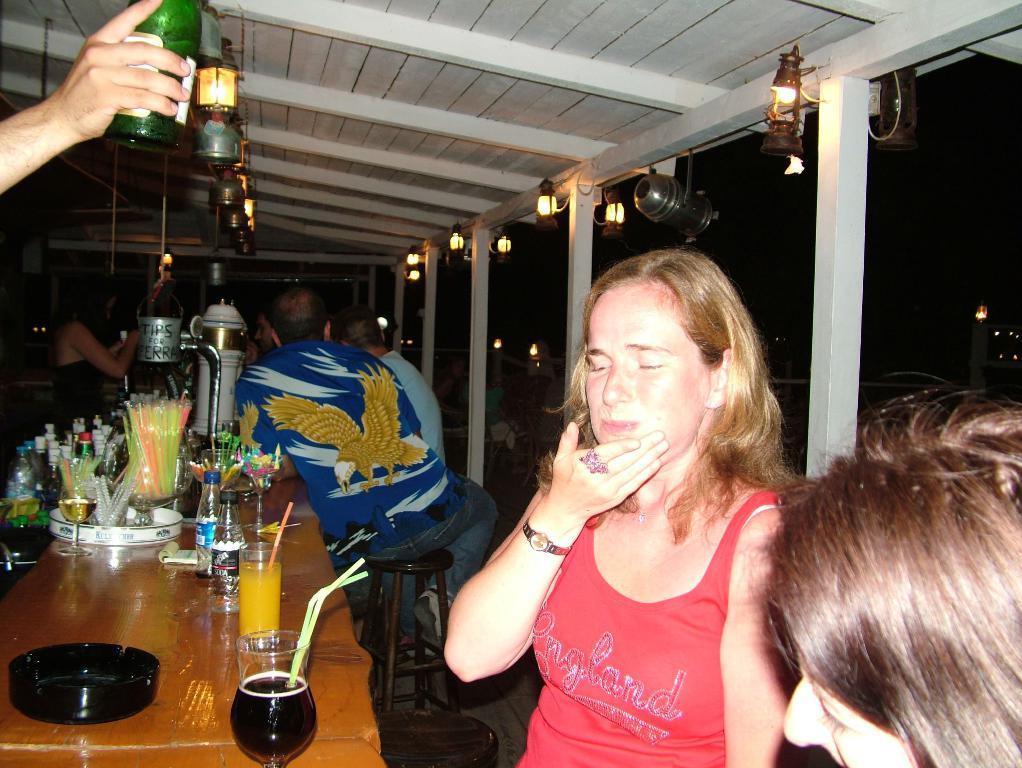Could you give a brief overview of what you see in this image? This picture describes about group of people, few are seated on the chairs, in front of them we can find few glasses, bottles, straw and other things on the table, in the top left hand corner we can see a person is holding a bottle, in the background we can find few lights. 